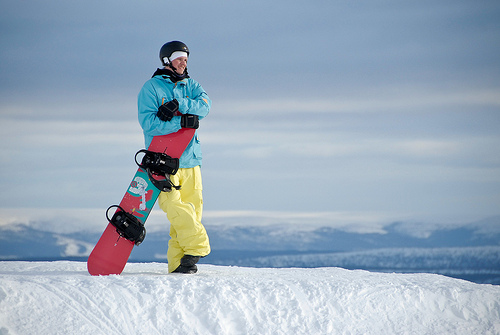Is the sky behind the snow orange and huge?
Answer the question using a single word or phrase. No How big is the sky behind the snow? Huge 